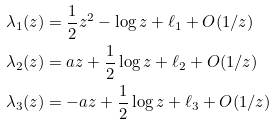<formula> <loc_0><loc_0><loc_500><loc_500>\lambda _ { 1 } ( z ) & = \frac { 1 } { 2 } z ^ { 2 } - \log z + \ell _ { 1 } + O ( 1 / z ) \\ \lambda _ { 2 } ( z ) & = a z + \frac { 1 } { 2 } \log z + \ell _ { 2 } + O ( 1 / z ) \\ \lambda _ { 3 } ( z ) & = - a z + \frac { 1 } { 2 } \log z + \ell _ { 3 } + O ( 1 / z )</formula> 